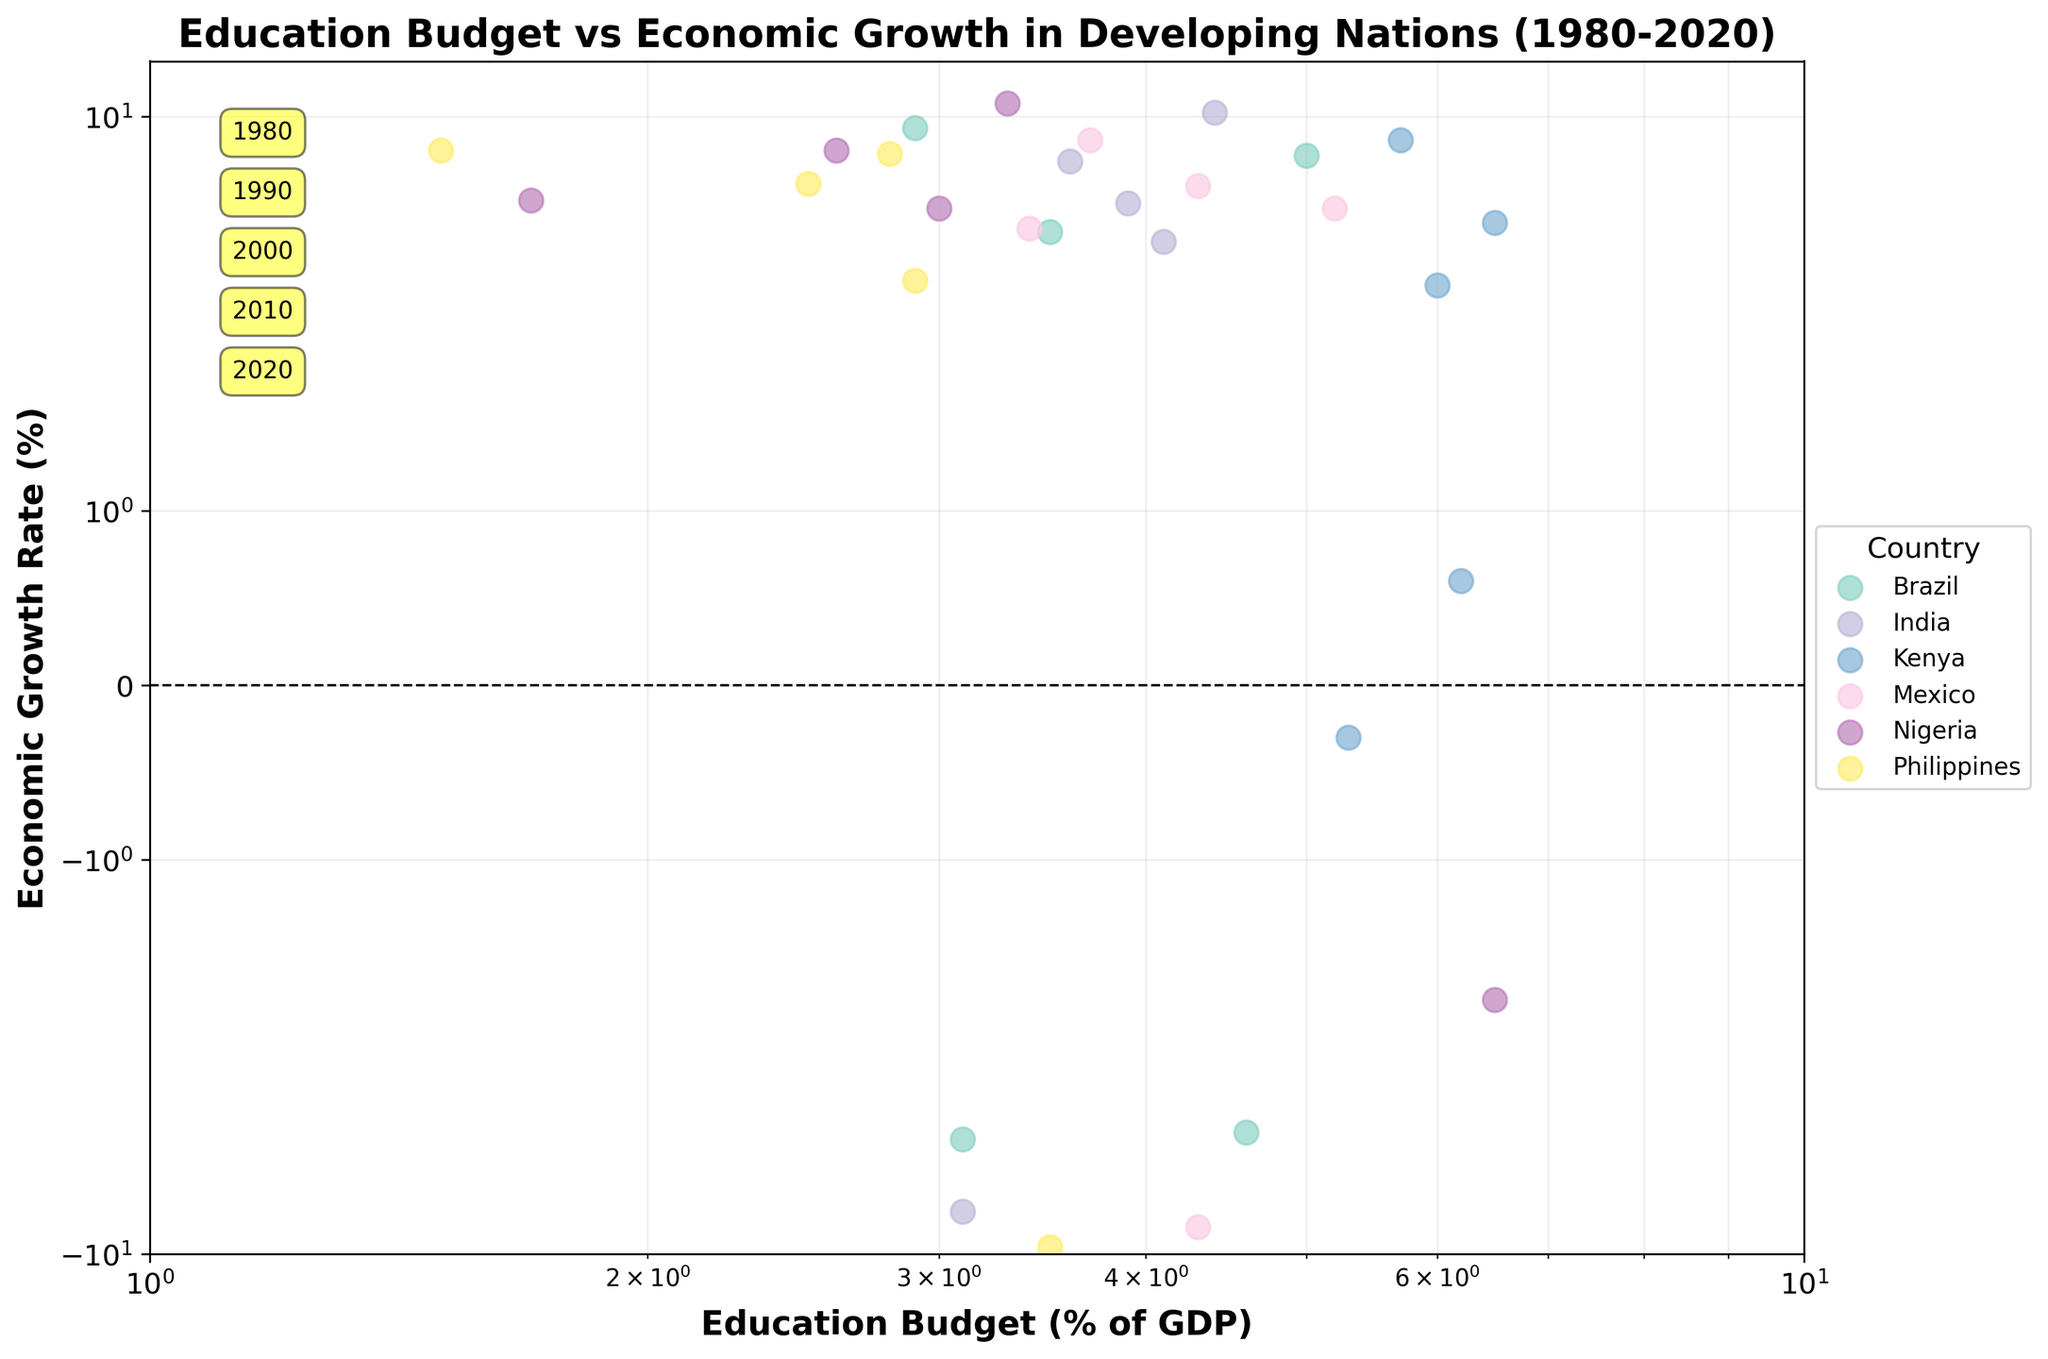What is the title of the chart? The title is usually at the top of the chart and is prominently displayed. Here, it's "Education Budget vs Economic Growth in Developing Nations (1980-2020)".
Answer: Education Budget vs Economic Growth in Developing Nations (1980-2020) Which country has the highest education budget in 2020? To identify the highest education budget in 2020, look for the data points labeled "2020" and compare the x-coordinates. Nigeria has the highest with 6.5% of GDP.
Answer: Nigeria What was Brazil's economic growth rate in 1990? Find Brazil's data points and locate the one labeled "1990", then check its y-coordinate. The economic growth rate is -4.3%.
Answer: -4.3% Which country had the highest economic growth rate in 1990? To find this, look at the data points labeled "1990" and compare the y-coordinates. Nigeria stands out with 11.0%.
Answer: Nigeria How many countries' data are represented in the chart? Each country is represented by a unique color and marker. By counting the legend entry, we see there are 6 countries.
Answer: 6 Which country showed a decreasing trend in the education budget percentage from 2000 to 2020? Compare the x-coordinates for each country from 2000 to 2020. Kenya shows a decrease from 6.2% to 5.3%.
Answer: Kenya What year has the annotation box located at the highest position? The annotation boxes are located from top to bottom. The highest position is marked as 1980.
Answer: 1980 Which country had the lowest GDP allocation for education in any given year? Look for the leftmost data point. The lowest is the Philippines in 1980 with 1.5%.
Answer: The Philippines How does Kenya's economic growth rate change from 2010 to 2020? Compare Kenya's y-coordinates for 2010 and 2020. The growth rate decreases from 8.4% to -0.3%.
Answer: It decreases Compare the economic growth rates of India and Mexico in 2020. Which one was worse? Look at the 2020 data points for both countries and compare the y-coordinates. India has a -7.3% growth rate and Mexico has -8.2%. Mexico's is worse.
Answer: Mexico 